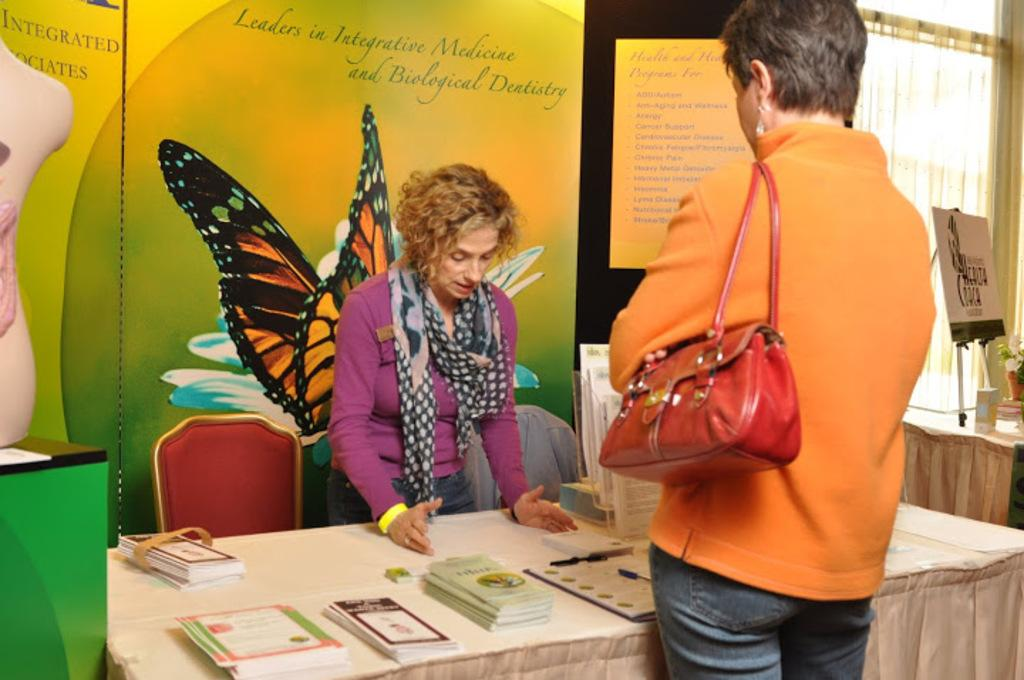What is the primary subject of the image? There is a woman standing in the image. Can you describe another person in the image? There is another person standing in the image. What can be seen in the background of the image? There are books, a table, a hoarding, and a curtain in the background of the image. What type of pan is being used by the woman in the image? There is no pan present in the image. What does the image smell like? The image does not have a smell, as it is a visual representation. 